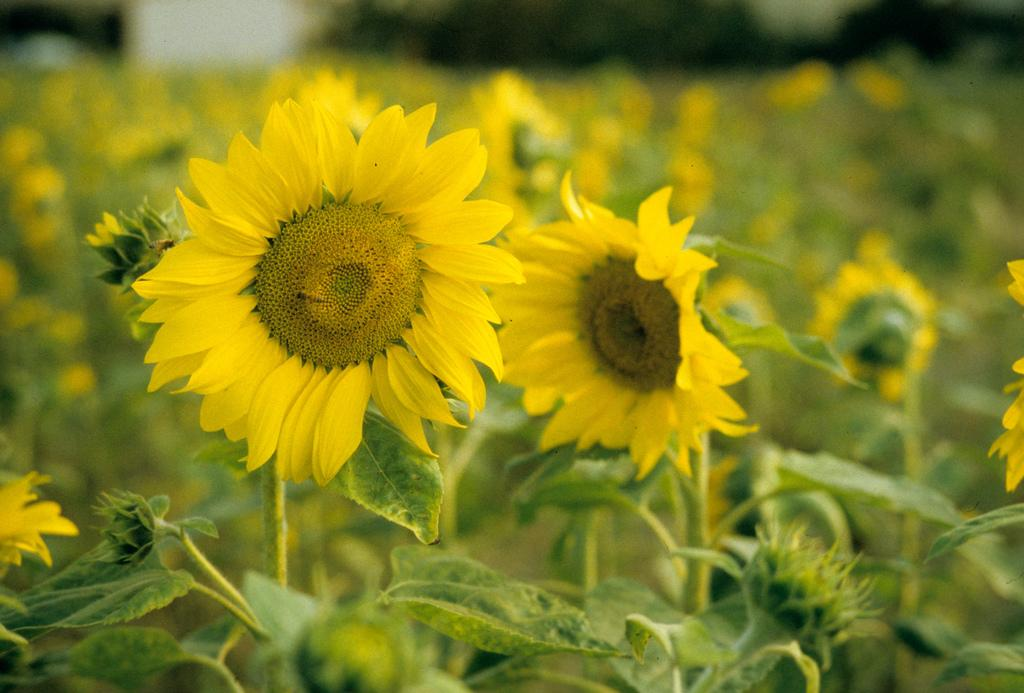What is the main subject of the image? The main subject of the image is many plants. What specific feature do the plants have? The plants have flowers. What color are the flowers? The flowers are yellow in color. What is a characteristic of the flowers? The flowers have petals. What type of mask is being worn by the flower in the image? There is no mask present in the image, as it features plants and flowers. 